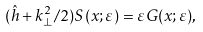Convert formula to latex. <formula><loc_0><loc_0><loc_500><loc_500>( \hat { h } + k ^ { 2 } _ { \perp } / 2 ) S ( x ; \varepsilon ) = \varepsilon G ( x ; \varepsilon ) ,</formula> 